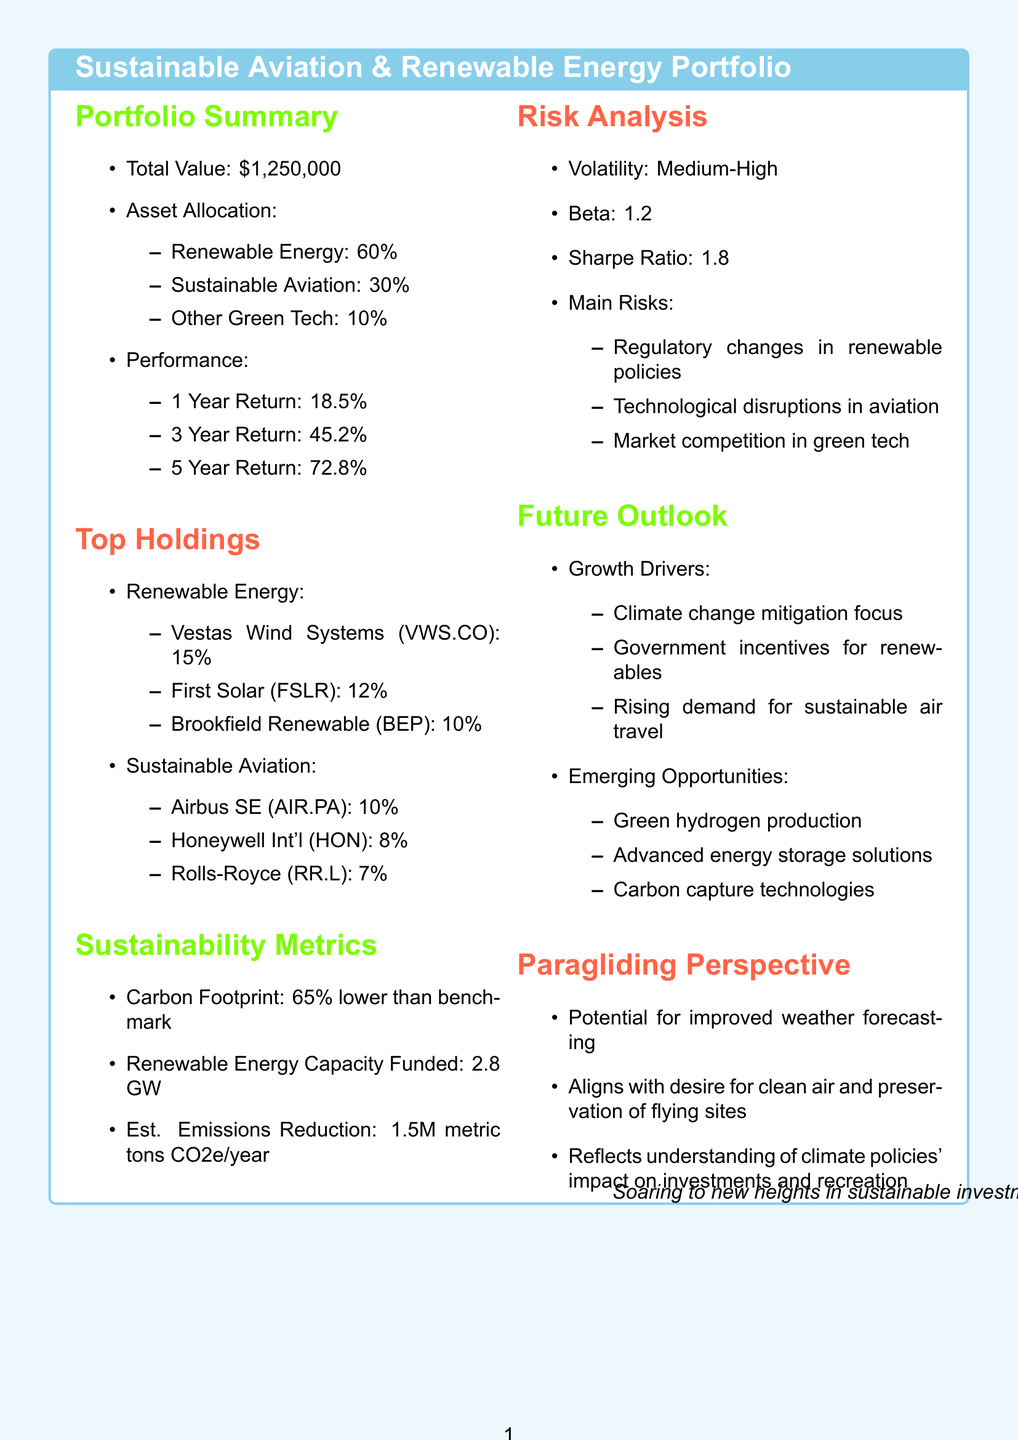What is the total value of the portfolio? The total value of the portfolio is stated in the summary section of the document.
Answer: $1,250,000 What percentage of the portfolio is allocated to renewable energy? The asset allocation section of the document specifies the allocation percentages for each category.
Answer: 60% What is the annual return of Vestas Wind Systems? The details for each renewable energy holding include their respective annual returns.
Answer: 22.3% What is the estimated emissions reduction annually? This figure is provided under the sustainability metrics section of the document, showing the overall impact of the investments.
Answer: 1.5 million metric tons CO2e annually What challenges are mentioned in the future outlook section? The future outlook section lists potential challenges that could affect the portfolio.
Answer: Supply chain disruptions in rare earth materials How does the portfolio's carbon footprint compare to the benchmark? The sustainability metrics section provides a comparative measurement of the portfolio's carbon footprint against a benchmark.
Answer: 65% lower than benchmark What percentage of the portfolio is invested in sustainable aviation technologies? The asset allocation clearly lists the percentage allocated specifically to sustainable aviation within the portfolio.
Answer: 30% Which company is involved in electric vertical takeoff and landing technology? The list of sustainable aviation holdings includes various companies, identifying their specific technologies.
Answer: Joby Aviation What is the Sharpe Ratio of the portfolio? The risk analysis section of the document details various risk metrics, including the Sharpe Ratio.
Answer: 1.8 